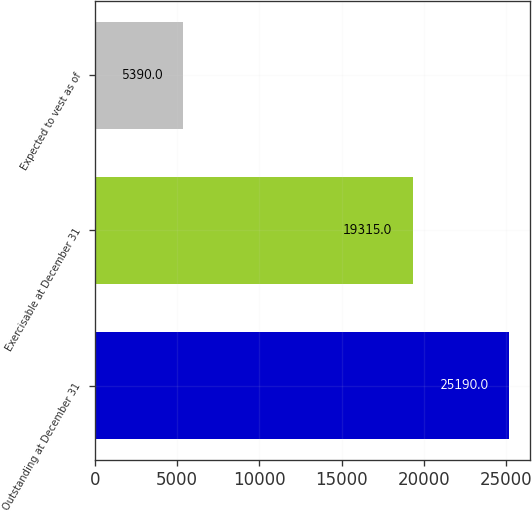Convert chart to OTSL. <chart><loc_0><loc_0><loc_500><loc_500><bar_chart><fcel>Outstanding at December 31<fcel>Exercisable at December 31<fcel>Expected to vest as of<nl><fcel>25190<fcel>19315<fcel>5390<nl></chart> 